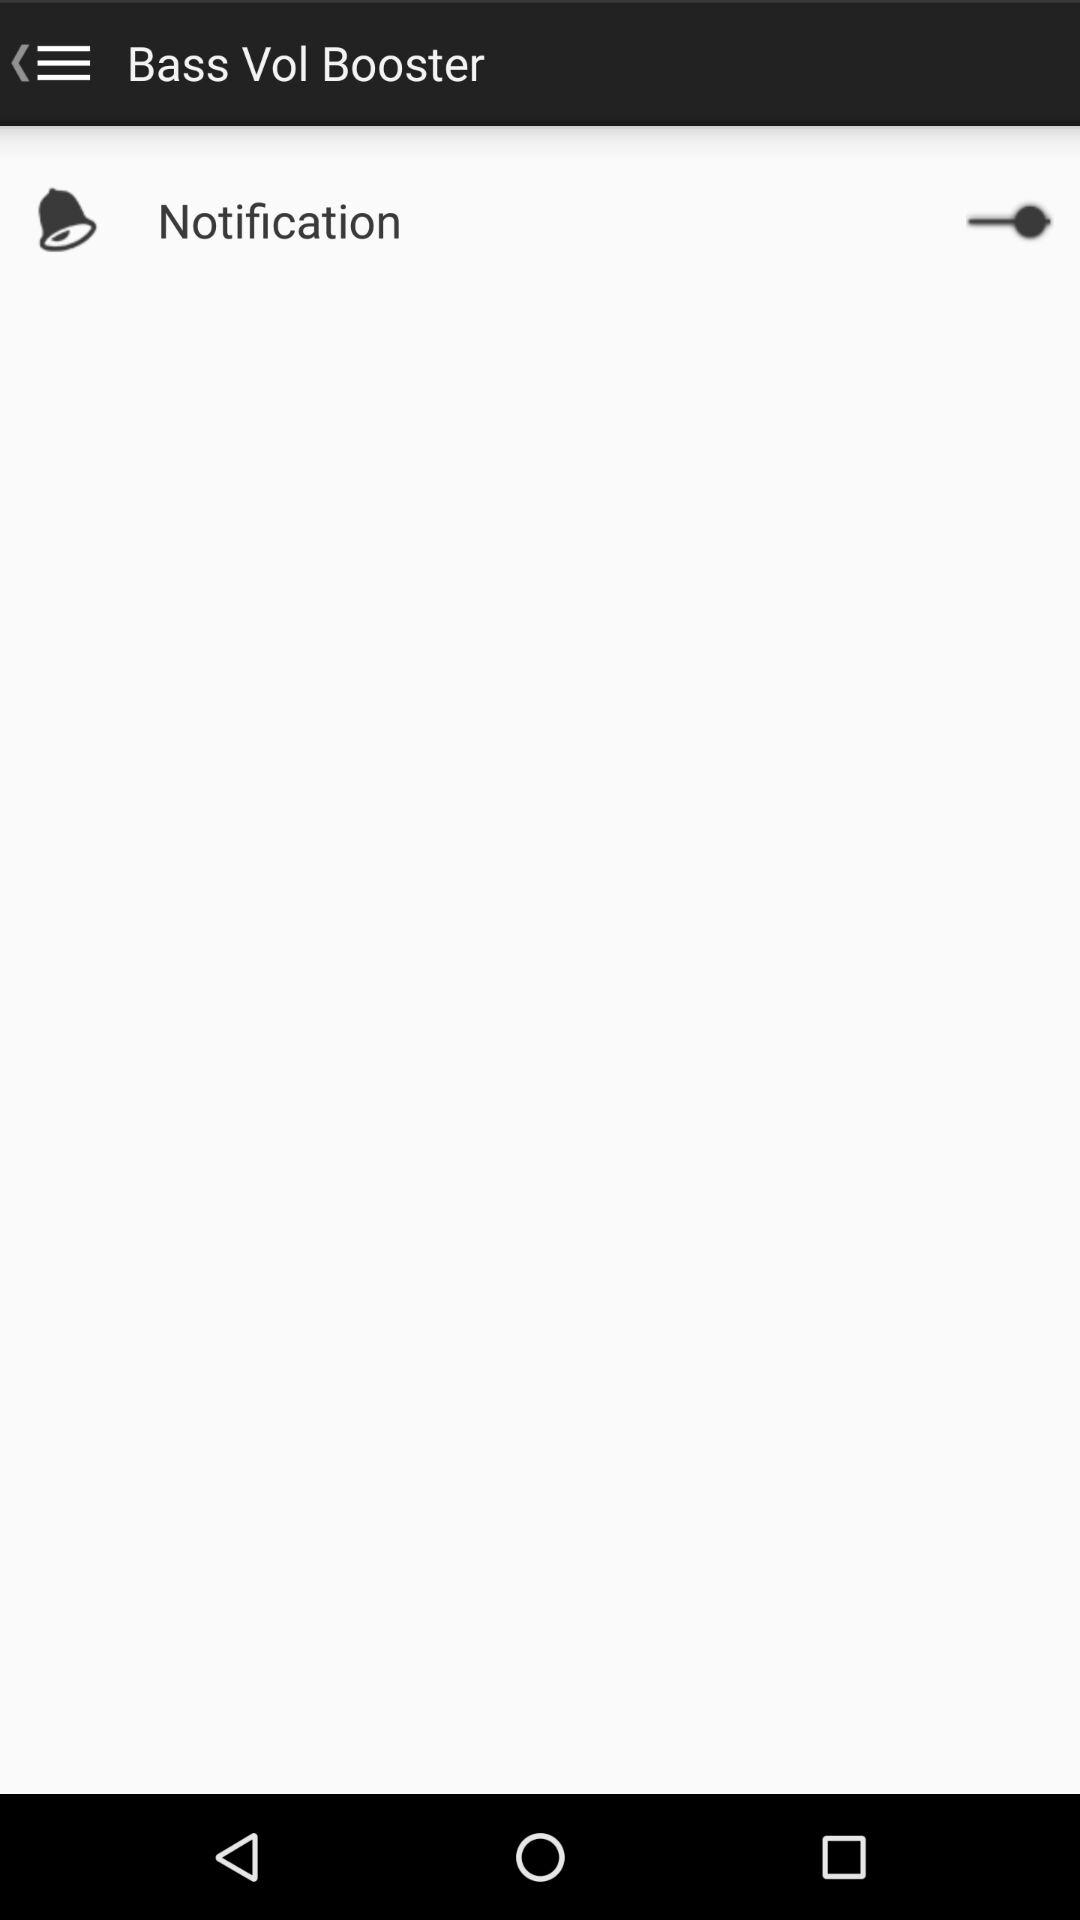What is the status of the "Notification"? The status of the "Notification" is "on". 